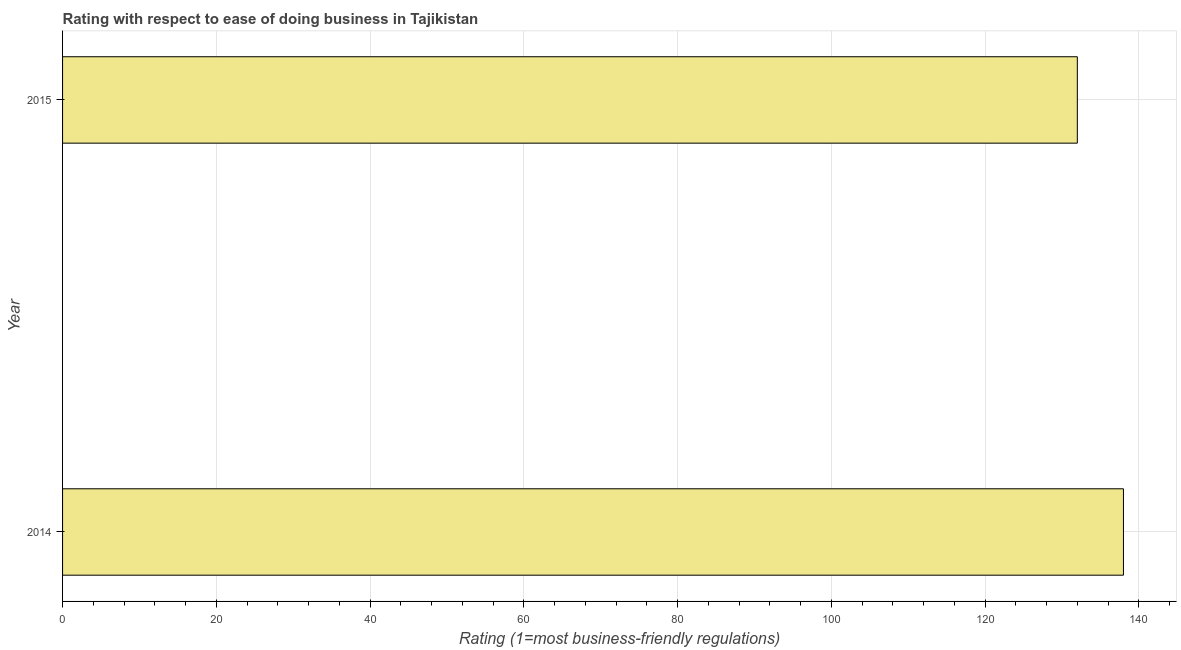Does the graph contain any zero values?
Provide a short and direct response. No. Does the graph contain grids?
Keep it short and to the point. Yes. What is the title of the graph?
Your answer should be compact. Rating with respect to ease of doing business in Tajikistan. What is the label or title of the X-axis?
Give a very brief answer. Rating (1=most business-friendly regulations). What is the label or title of the Y-axis?
Ensure brevity in your answer.  Year. What is the ease of doing business index in 2015?
Provide a short and direct response. 132. Across all years, what is the maximum ease of doing business index?
Your answer should be very brief. 138. Across all years, what is the minimum ease of doing business index?
Offer a terse response. 132. In which year was the ease of doing business index maximum?
Your response must be concise. 2014. In which year was the ease of doing business index minimum?
Keep it short and to the point. 2015. What is the sum of the ease of doing business index?
Keep it short and to the point. 270. What is the difference between the ease of doing business index in 2014 and 2015?
Offer a terse response. 6. What is the average ease of doing business index per year?
Make the answer very short. 135. What is the median ease of doing business index?
Ensure brevity in your answer.  135. In how many years, is the ease of doing business index greater than 88 ?
Offer a very short reply. 2. Do a majority of the years between 2015 and 2014 (inclusive) have ease of doing business index greater than 52 ?
Provide a short and direct response. No. What is the ratio of the ease of doing business index in 2014 to that in 2015?
Offer a very short reply. 1.04. In how many years, is the ease of doing business index greater than the average ease of doing business index taken over all years?
Your response must be concise. 1. What is the Rating (1=most business-friendly regulations) in 2014?
Make the answer very short. 138. What is the Rating (1=most business-friendly regulations) of 2015?
Give a very brief answer. 132. What is the ratio of the Rating (1=most business-friendly regulations) in 2014 to that in 2015?
Keep it short and to the point. 1.04. 